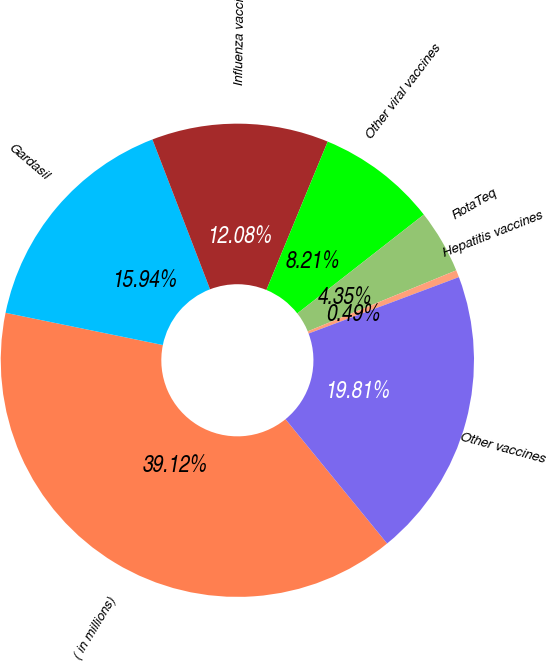Convert chart to OTSL. <chart><loc_0><loc_0><loc_500><loc_500><pie_chart><fcel>( in millions)<fcel>Gardasil<fcel>Influenza vaccines<fcel>Other viral vaccines<fcel>RotaTeq<fcel>Hepatitis vaccines<fcel>Other vaccines<nl><fcel>39.12%<fcel>15.94%<fcel>12.08%<fcel>8.21%<fcel>4.35%<fcel>0.49%<fcel>19.81%<nl></chart> 